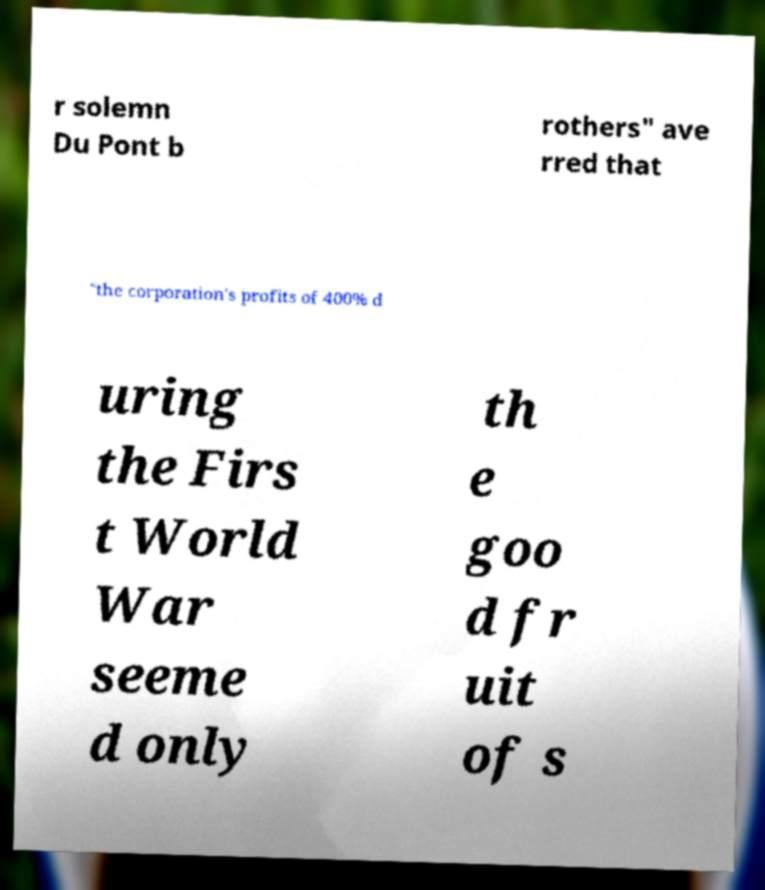Could you assist in decoding the text presented in this image and type it out clearly? r solemn Du Pont b rothers" ave rred that "the corporation's profits of 400% d uring the Firs t World War seeme d only th e goo d fr uit of s 